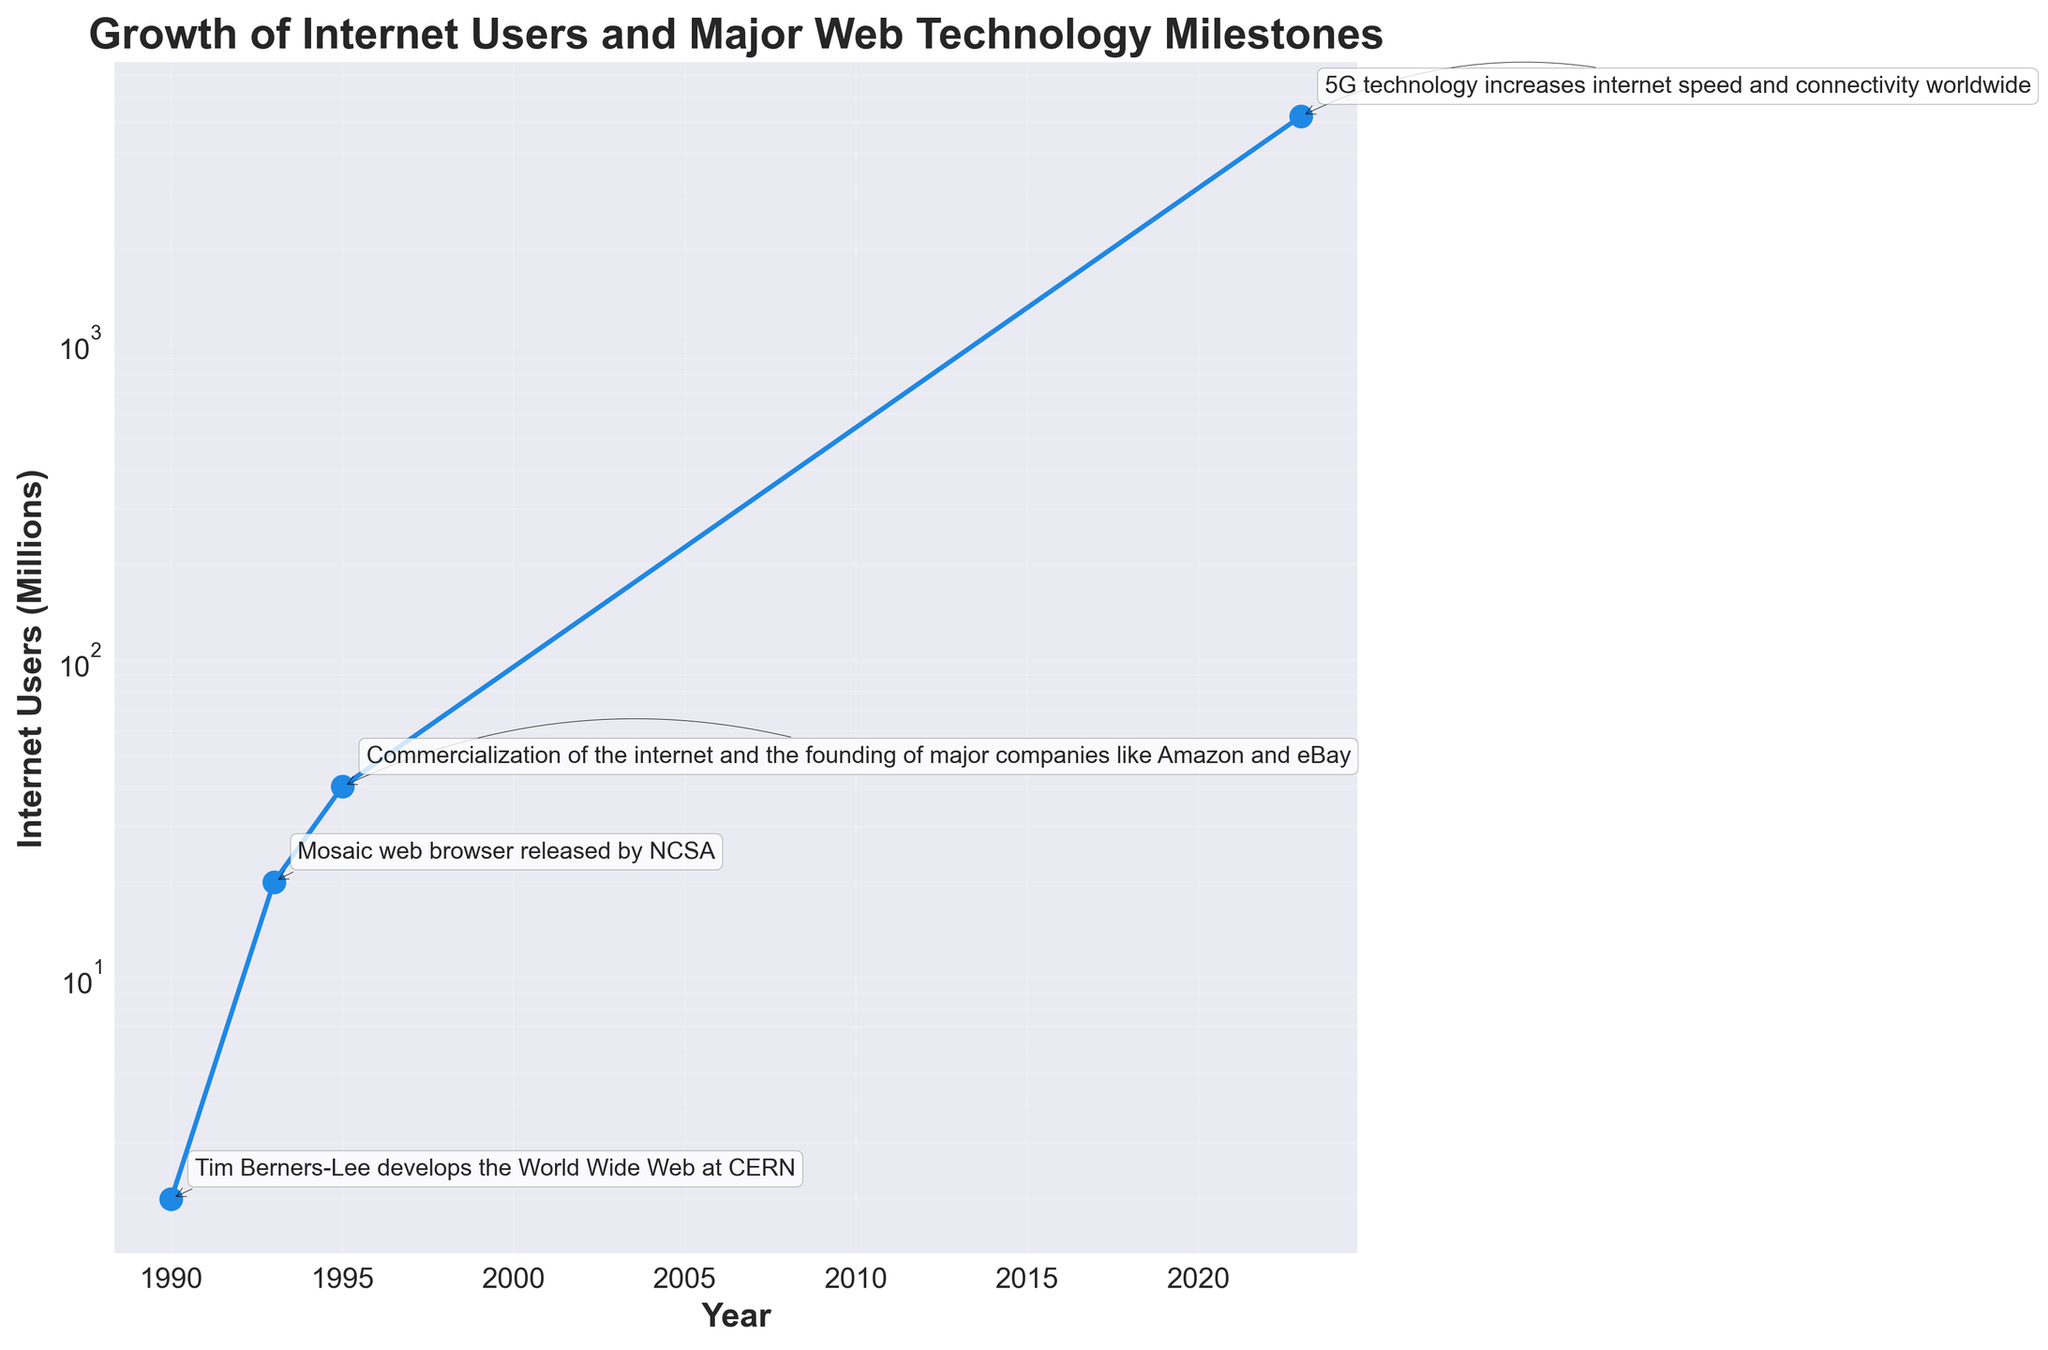What is the titel of the chart? The chart's title can be found at the top of the figure, and it is written in bold text. It provides an overview of what the chart represents.
Answer: Growth of Internet Users and Major Web Technology Milestones Between which years did the number of Internet users increase from 2 million to 20 million? To find the answer, look at the x-axis (years) and the y-axis (Internet Users) to see where the values 2 million and 20 million fall. The annotated milestones can also help.
Answer: 1990 to 1993 What is the earliest technological milestone recorded in the chart? The earliest milestone is indicated by the first annotation on the timeline, describing a development or event in web technology.
Answer: Tim Berners-Lee develops the World Wide Web at CERN How many major milestones are annotated in the chart? To determine this, count the number of annotations (text boxes) that correspond to the milestones on the chart.
Answer: 4 What is the milestone associated with the year 2023? Look at the x-axis for the year 2023 and find the corresponding annotation for the milestone.
Answer: 5G technology increases internet speed and connectivity worldwide How much did the number of Internet users increase between 1993 and 1995? Find the number of users at both indicated years and calculate the difference between these two values (40 million - 20 million = 20 million).
Answer: 20 million Which milestone in the chart marks the beginning of the commercialization of the internet? Look at the annotations for the milestone that describes the commercialization of the internet, particularly around the mid-1990s.
Answer: Commercialization of the internet and the founding of major companies like Amazon and eBay What range of years does the chart cover? Identify the earliest and latest years on the x-axis of the chart to determine the range of years covered.
Answer: 1990 to 2023 How many years did it take for the number of Internet users to increase from 20 million to 5200 million? Identify the years corresponding to 20 million and 5200 million Internet users and calculate the difference in years (2023 - 1993).
Answer: 30 years Did the growth rate of internet users increase or decrease after the release of the Mosaic web browser in 1993? Observe the slope of the line before and after 1993. If it becomes steeper after 1993, the growth rate increased; otherwise, it decreased.
Answer: Increase 